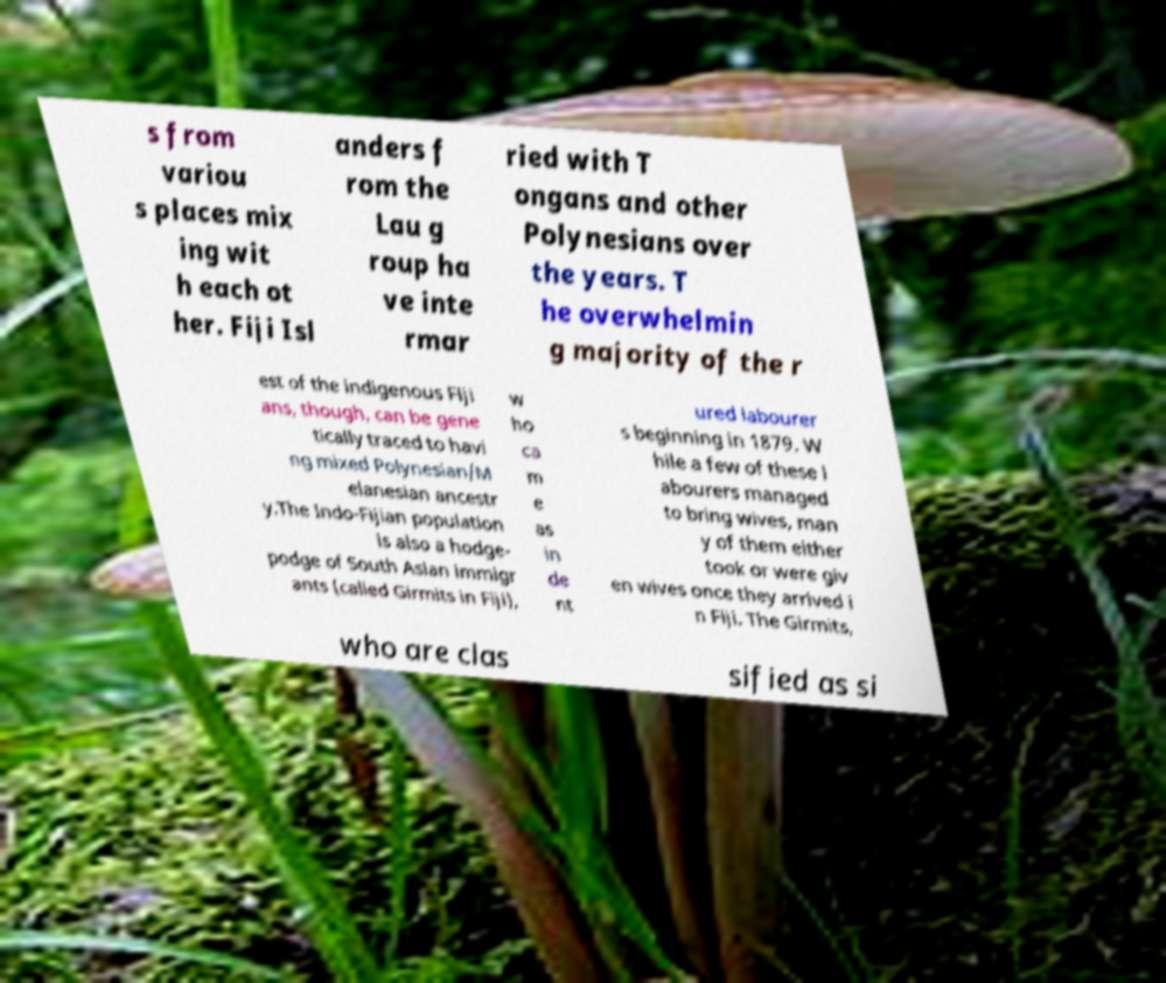Please identify and transcribe the text found in this image. s from variou s places mix ing wit h each ot her. Fiji Isl anders f rom the Lau g roup ha ve inte rmar ried with T ongans and other Polynesians over the years. T he overwhelmin g majority of the r est of the indigenous Fiji ans, though, can be gene tically traced to havi ng mixed Polynesian/M elanesian ancestr y.The Indo-Fijian population is also a hodge- podge of South Asian immigr ants (called Girmits in Fiji), w ho ca m e as in de nt ured labourer s beginning in 1879. W hile a few of these l abourers managed to bring wives, man y of them either took or were giv en wives once they arrived i n Fiji. The Girmits, who are clas sified as si 